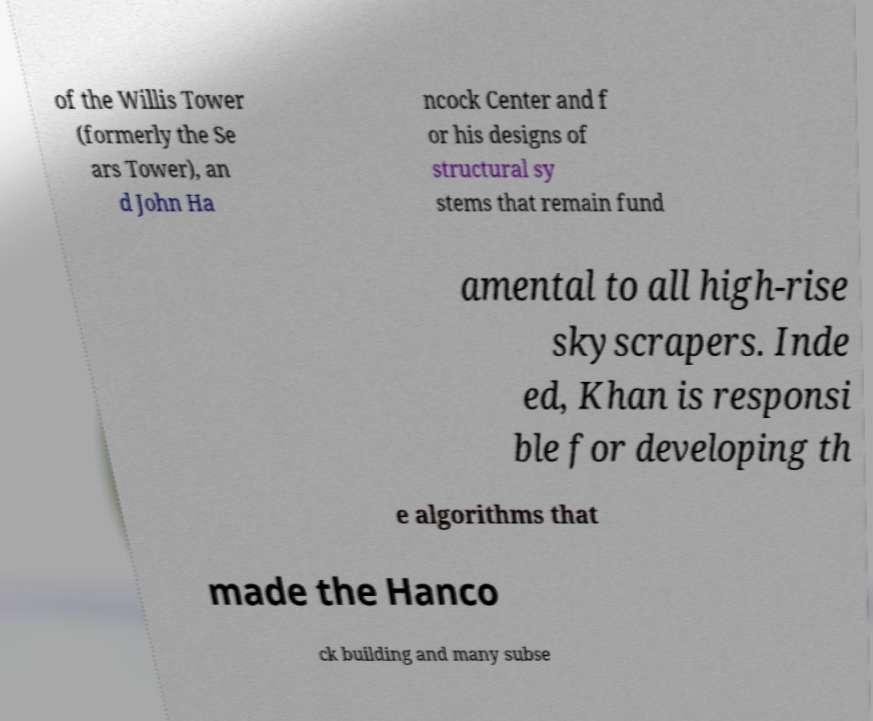Could you assist in decoding the text presented in this image and type it out clearly? of the Willis Tower (formerly the Se ars Tower), an d John Ha ncock Center and f or his designs of structural sy stems that remain fund amental to all high-rise skyscrapers. Inde ed, Khan is responsi ble for developing th e algorithms that made the Hanco ck building and many subse 